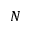Convert formula to latex. <formula><loc_0><loc_0><loc_500><loc_500>N</formula> 